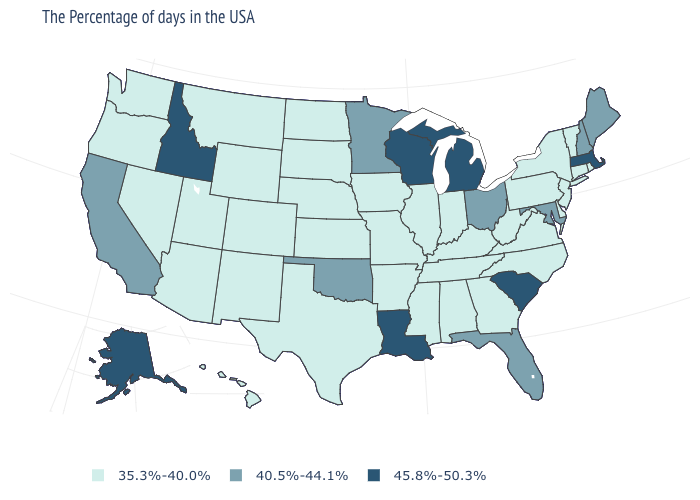Does the map have missing data?
Short answer required. No. Among the states that border Utah , does Idaho have the highest value?
Give a very brief answer. Yes. Does Georgia have a lower value than Idaho?
Write a very short answer. Yes. How many symbols are there in the legend?
Write a very short answer. 3. Among the states that border Indiana , does Kentucky have the lowest value?
Keep it brief. Yes. Name the states that have a value in the range 40.5%-44.1%?
Answer briefly. Maine, New Hampshire, Maryland, Ohio, Florida, Minnesota, Oklahoma, California. Does the map have missing data?
Quick response, please. No. Does the first symbol in the legend represent the smallest category?
Short answer required. Yes. What is the value of Maine?
Give a very brief answer. 40.5%-44.1%. Does Louisiana have the highest value in the South?
Quick response, please. Yes. Name the states that have a value in the range 35.3%-40.0%?
Give a very brief answer. Rhode Island, Vermont, Connecticut, New York, New Jersey, Delaware, Pennsylvania, Virginia, North Carolina, West Virginia, Georgia, Kentucky, Indiana, Alabama, Tennessee, Illinois, Mississippi, Missouri, Arkansas, Iowa, Kansas, Nebraska, Texas, South Dakota, North Dakota, Wyoming, Colorado, New Mexico, Utah, Montana, Arizona, Nevada, Washington, Oregon, Hawaii. Name the states that have a value in the range 35.3%-40.0%?
Keep it brief. Rhode Island, Vermont, Connecticut, New York, New Jersey, Delaware, Pennsylvania, Virginia, North Carolina, West Virginia, Georgia, Kentucky, Indiana, Alabama, Tennessee, Illinois, Mississippi, Missouri, Arkansas, Iowa, Kansas, Nebraska, Texas, South Dakota, North Dakota, Wyoming, Colorado, New Mexico, Utah, Montana, Arizona, Nevada, Washington, Oregon, Hawaii. Name the states that have a value in the range 45.8%-50.3%?
Keep it brief. Massachusetts, South Carolina, Michigan, Wisconsin, Louisiana, Idaho, Alaska. Does Missouri have the lowest value in the USA?
Answer briefly. Yes. Name the states that have a value in the range 35.3%-40.0%?
Quick response, please. Rhode Island, Vermont, Connecticut, New York, New Jersey, Delaware, Pennsylvania, Virginia, North Carolina, West Virginia, Georgia, Kentucky, Indiana, Alabama, Tennessee, Illinois, Mississippi, Missouri, Arkansas, Iowa, Kansas, Nebraska, Texas, South Dakota, North Dakota, Wyoming, Colorado, New Mexico, Utah, Montana, Arizona, Nevada, Washington, Oregon, Hawaii. 